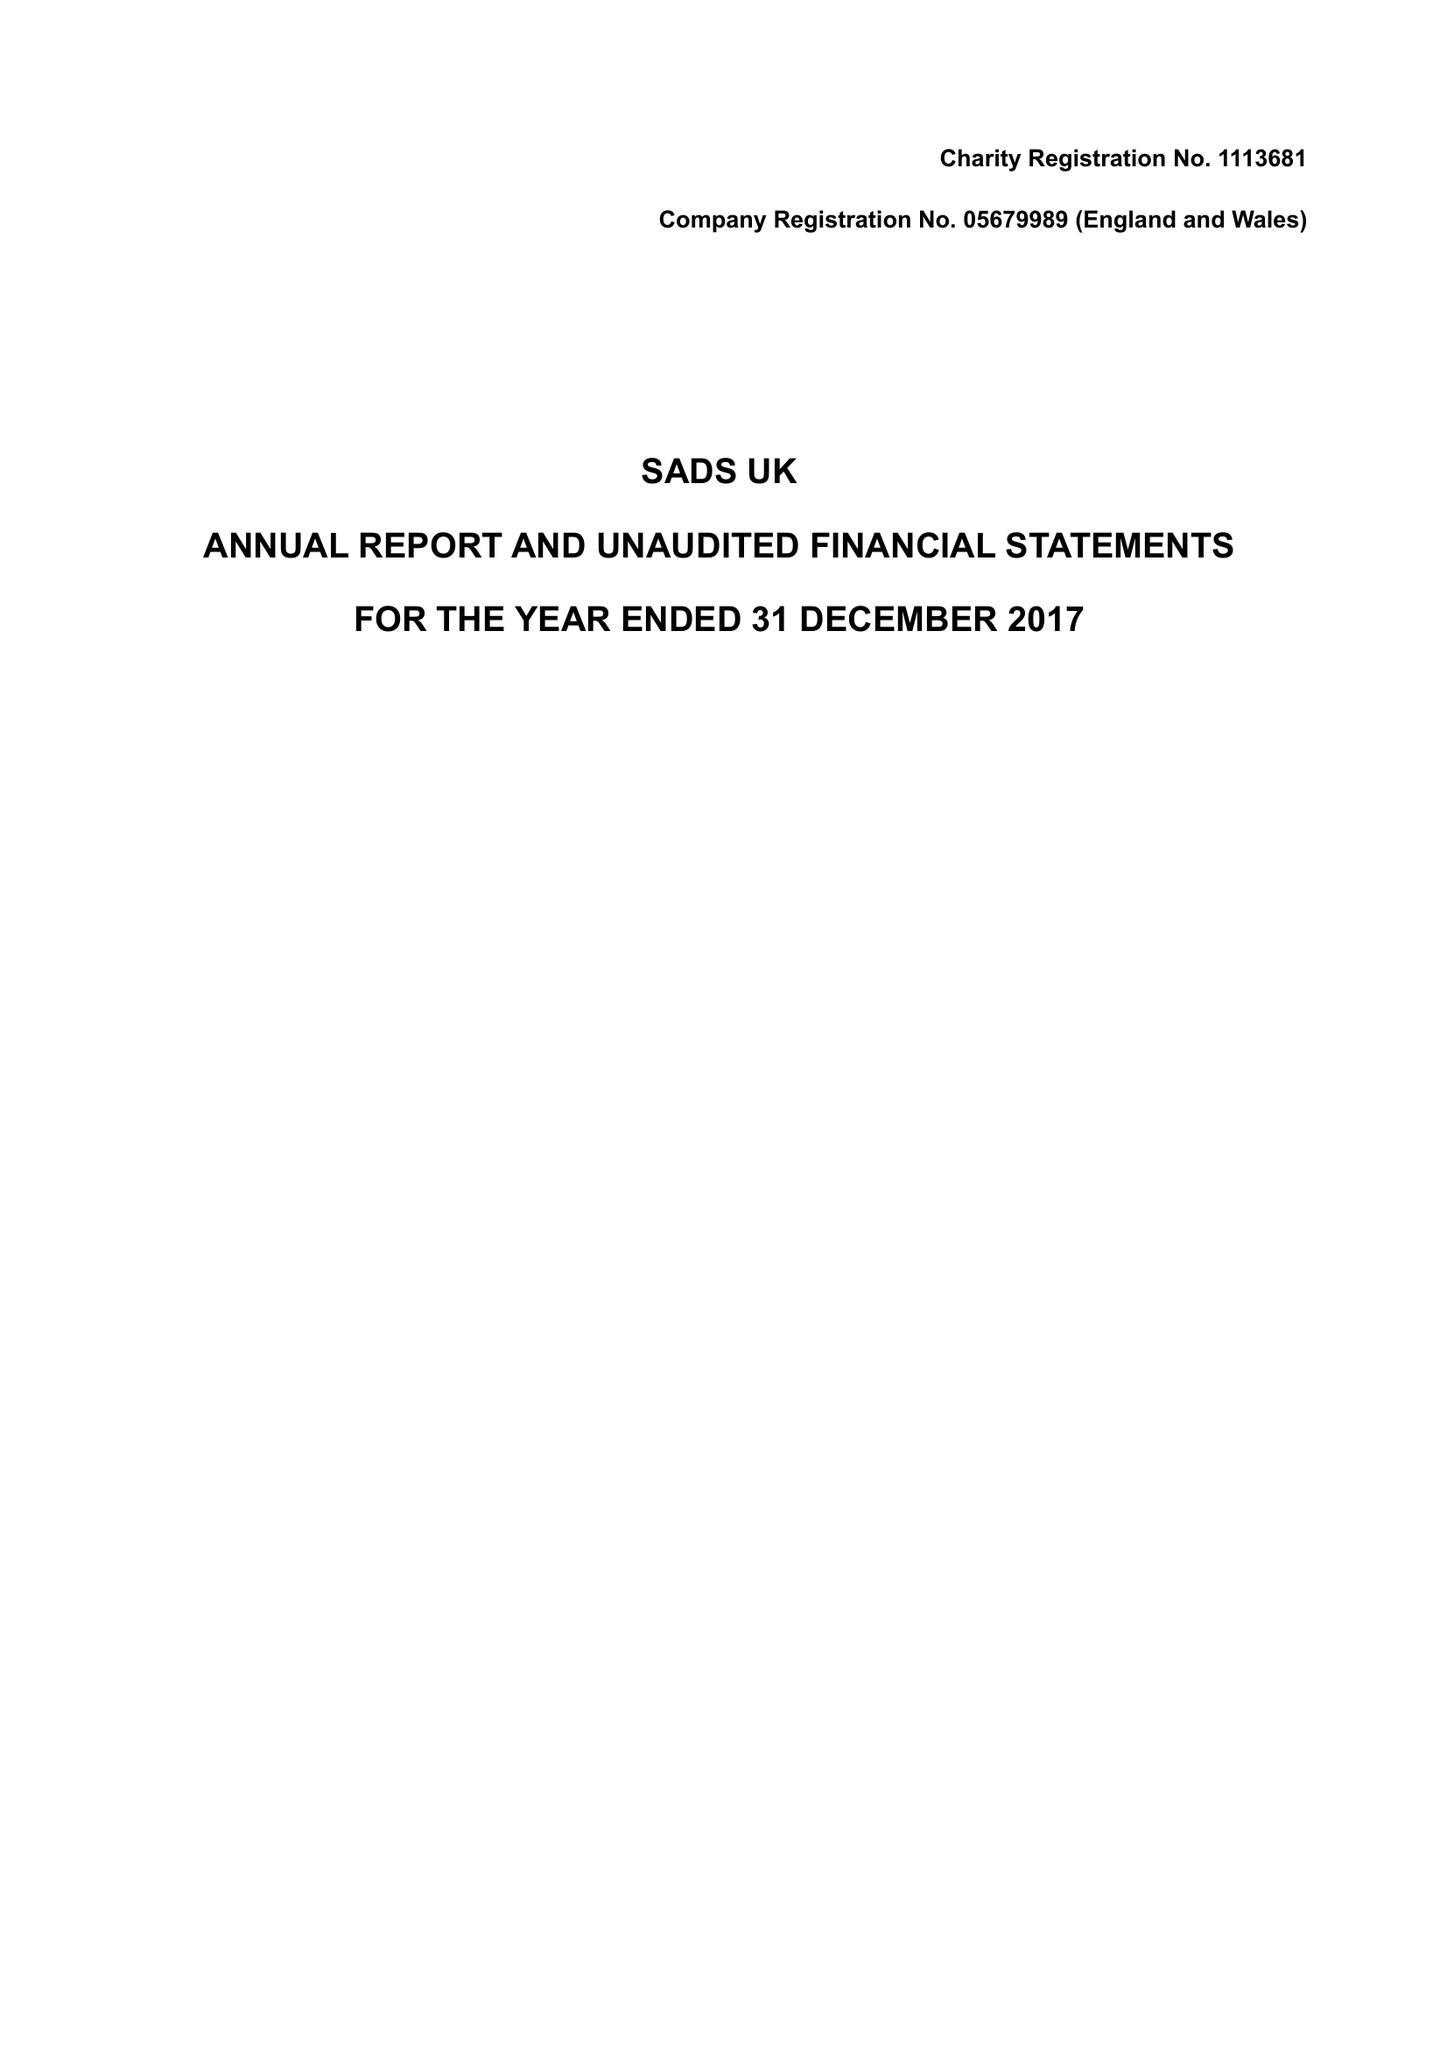What is the value for the report_date?
Answer the question using a single word or phrase. 2017-12-31 